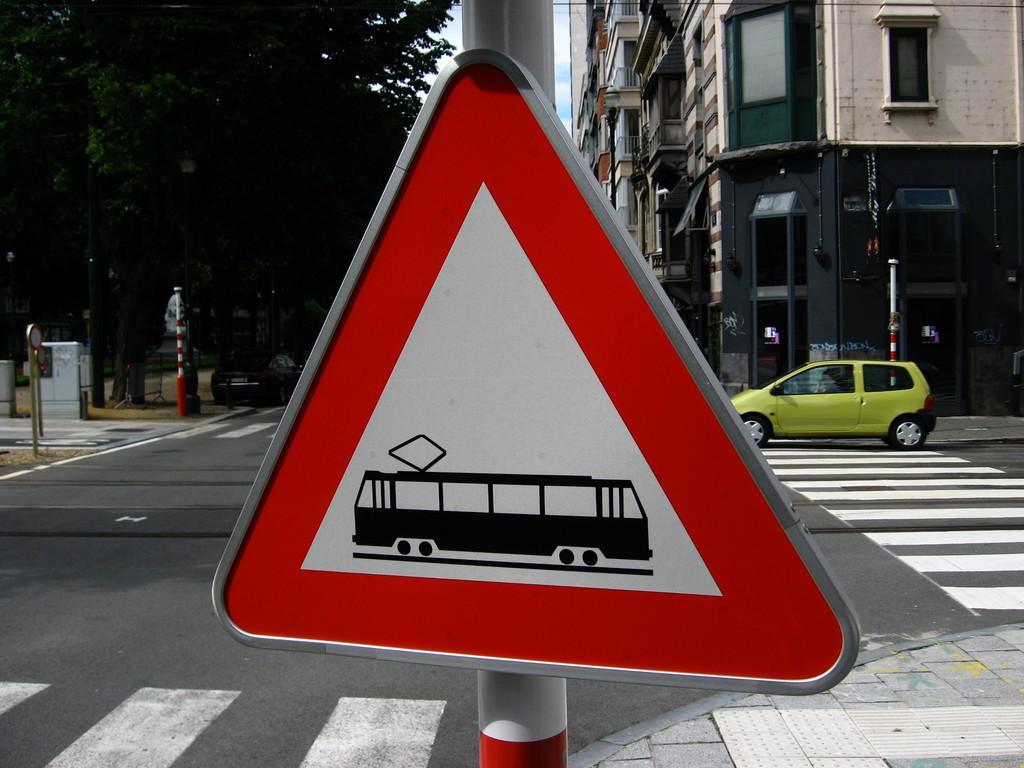Can you describe this image briefly? In this image we can see boards, poles, road, vehicles, trees, and buildings. 